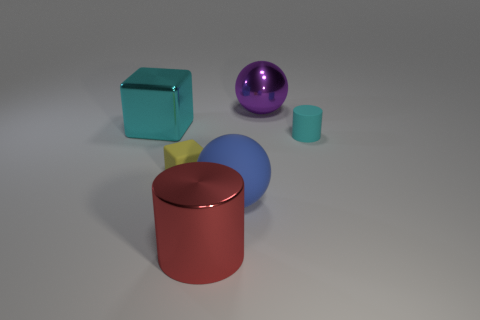What is the color of the large metal cylinder? The large metal cylinder in the image is a vibrant shade of red. Its glossy finish catches the light, enhancing its color intensity and making it a striking element in the composition. 